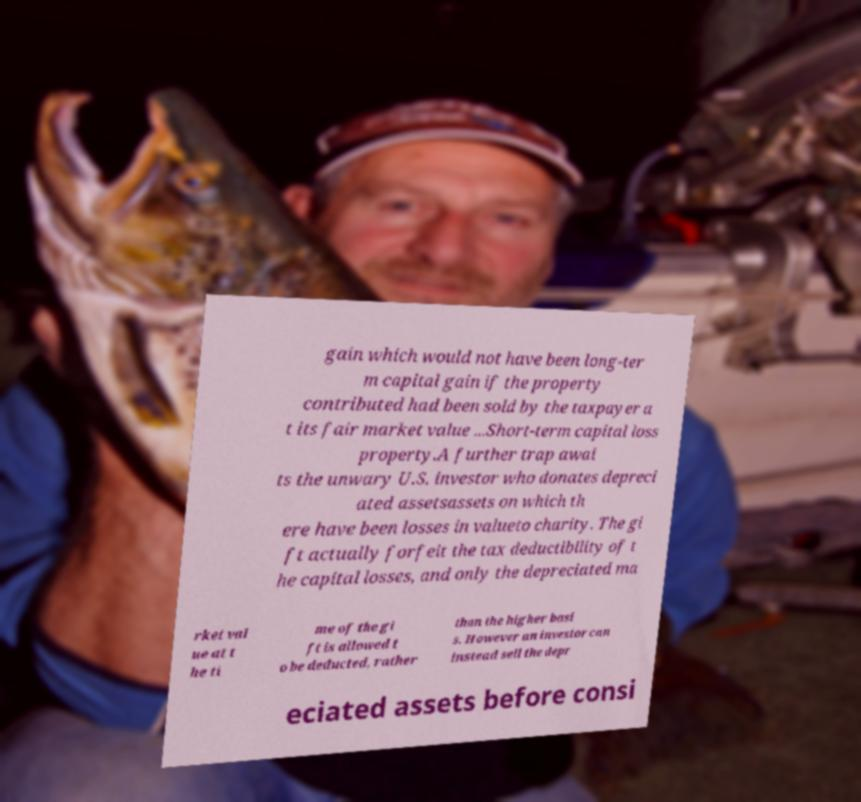There's text embedded in this image that I need extracted. Can you transcribe it verbatim? gain which would not have been long-ter m capital gain if the property contributed had been sold by the taxpayer a t its fair market value ...Short-term capital loss property.A further trap awai ts the unwary U.S. investor who donates depreci ated assetsassets on which th ere have been losses in valueto charity. The gi ft actually forfeit the tax deductibility of t he capital losses, and only the depreciated ma rket val ue at t he ti me of the gi ft is allowed t o be deducted, rather than the higher basi s. However an investor can instead sell the depr eciated assets before consi 